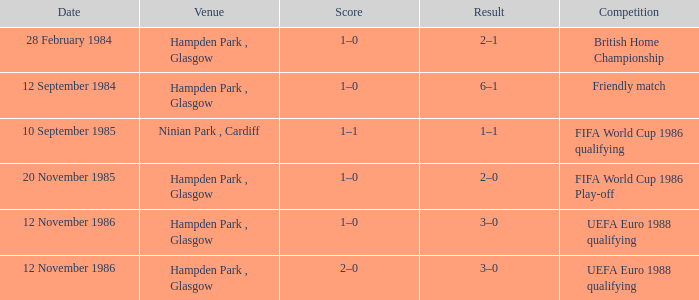What is the Score of the Fifa World Cup 1986 Qualifying Competition? 1–1. 